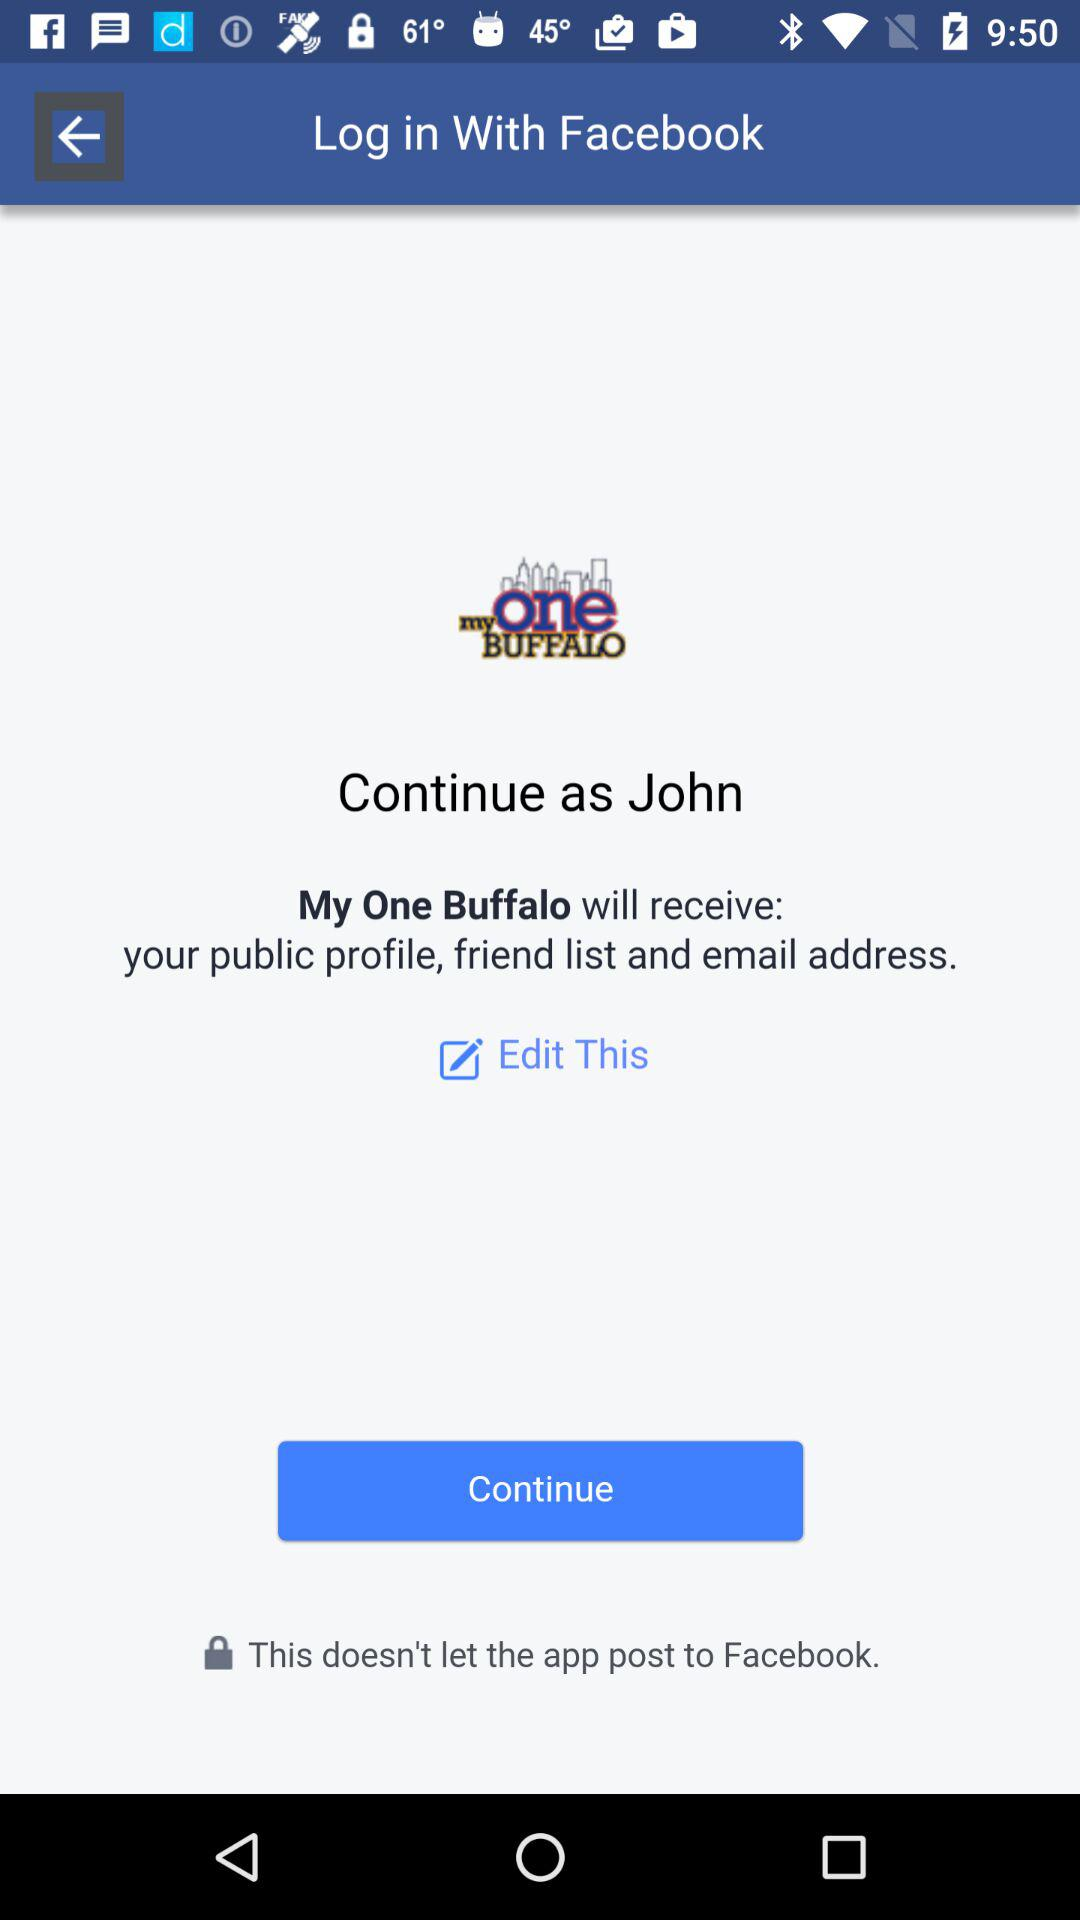What application is asking for permission? The application is "My One Buffalo". 